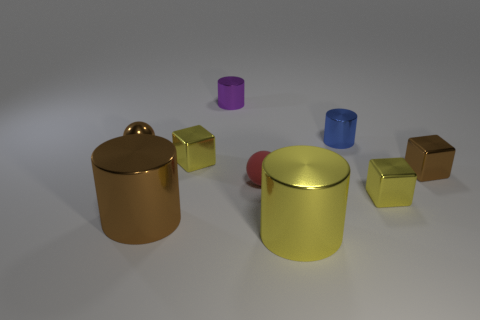Add 1 green balls. How many objects exist? 10 Subtract all brown cubes. How many cubes are left? 2 Subtract all blue cylinders. Subtract all tiny red matte things. How many objects are left? 7 Add 5 tiny matte balls. How many tiny matte balls are left? 6 Add 3 tiny metal objects. How many tiny metal objects exist? 9 Subtract all brown blocks. How many blocks are left? 2 Subtract 0 yellow spheres. How many objects are left? 9 Subtract all blocks. How many objects are left? 6 Subtract 2 cylinders. How many cylinders are left? 2 Subtract all gray spheres. Subtract all blue cubes. How many spheres are left? 2 